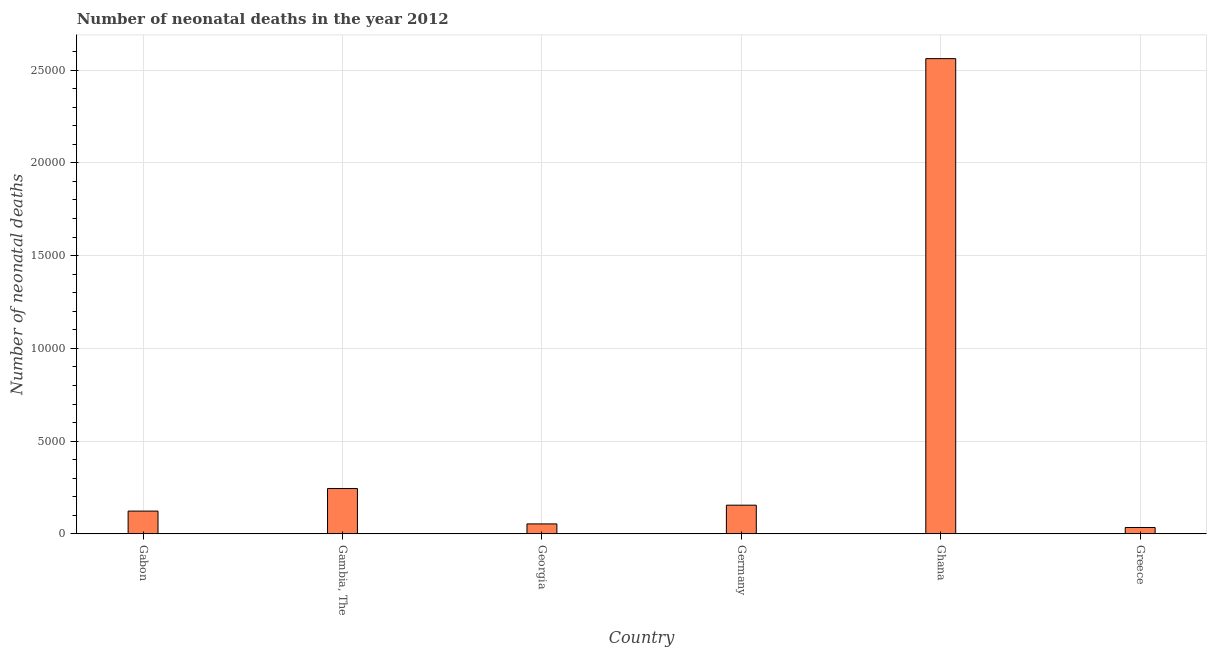Does the graph contain grids?
Your response must be concise. Yes. What is the title of the graph?
Keep it short and to the point. Number of neonatal deaths in the year 2012. What is the label or title of the X-axis?
Keep it short and to the point. Country. What is the label or title of the Y-axis?
Offer a very short reply. Number of neonatal deaths. What is the number of neonatal deaths in Ghana?
Keep it short and to the point. 2.56e+04. Across all countries, what is the maximum number of neonatal deaths?
Offer a terse response. 2.56e+04. Across all countries, what is the minimum number of neonatal deaths?
Provide a succinct answer. 343. In which country was the number of neonatal deaths maximum?
Provide a succinct answer. Ghana. What is the sum of the number of neonatal deaths?
Offer a very short reply. 3.17e+04. What is the difference between the number of neonatal deaths in Georgia and Greece?
Your answer should be compact. 193. What is the average number of neonatal deaths per country?
Provide a succinct answer. 5285. What is the median number of neonatal deaths?
Your answer should be compact. 1387. In how many countries, is the number of neonatal deaths greater than 11000 ?
Your answer should be very brief. 1. What is the ratio of the number of neonatal deaths in Gambia, The to that in Ghana?
Your response must be concise. 0.1. Is the number of neonatal deaths in Gabon less than that in Greece?
Your answer should be very brief. No. Is the difference between the number of neonatal deaths in Gambia, The and Ghana greater than the difference between any two countries?
Offer a very short reply. No. What is the difference between the highest and the second highest number of neonatal deaths?
Your response must be concise. 2.32e+04. Is the sum of the number of neonatal deaths in Gabon and Greece greater than the maximum number of neonatal deaths across all countries?
Give a very brief answer. No. What is the difference between the highest and the lowest number of neonatal deaths?
Provide a succinct answer. 2.53e+04. In how many countries, is the number of neonatal deaths greater than the average number of neonatal deaths taken over all countries?
Provide a short and direct response. 1. How many bars are there?
Make the answer very short. 6. Are all the bars in the graph horizontal?
Offer a terse response. No. Are the values on the major ticks of Y-axis written in scientific E-notation?
Give a very brief answer. No. What is the Number of neonatal deaths in Gabon?
Make the answer very short. 1228. What is the Number of neonatal deaths of Gambia, The?
Provide a succinct answer. 2443. What is the Number of neonatal deaths of Georgia?
Provide a succinct answer. 536. What is the Number of neonatal deaths in Germany?
Make the answer very short. 1546. What is the Number of neonatal deaths of Ghana?
Provide a short and direct response. 2.56e+04. What is the Number of neonatal deaths of Greece?
Give a very brief answer. 343. What is the difference between the Number of neonatal deaths in Gabon and Gambia, The?
Your answer should be compact. -1215. What is the difference between the Number of neonatal deaths in Gabon and Georgia?
Offer a terse response. 692. What is the difference between the Number of neonatal deaths in Gabon and Germany?
Provide a succinct answer. -318. What is the difference between the Number of neonatal deaths in Gabon and Ghana?
Provide a short and direct response. -2.44e+04. What is the difference between the Number of neonatal deaths in Gabon and Greece?
Make the answer very short. 885. What is the difference between the Number of neonatal deaths in Gambia, The and Georgia?
Your answer should be very brief. 1907. What is the difference between the Number of neonatal deaths in Gambia, The and Germany?
Make the answer very short. 897. What is the difference between the Number of neonatal deaths in Gambia, The and Ghana?
Provide a short and direct response. -2.32e+04. What is the difference between the Number of neonatal deaths in Gambia, The and Greece?
Ensure brevity in your answer.  2100. What is the difference between the Number of neonatal deaths in Georgia and Germany?
Keep it short and to the point. -1010. What is the difference between the Number of neonatal deaths in Georgia and Ghana?
Ensure brevity in your answer.  -2.51e+04. What is the difference between the Number of neonatal deaths in Georgia and Greece?
Give a very brief answer. 193. What is the difference between the Number of neonatal deaths in Germany and Ghana?
Offer a terse response. -2.41e+04. What is the difference between the Number of neonatal deaths in Germany and Greece?
Offer a terse response. 1203. What is the difference between the Number of neonatal deaths in Ghana and Greece?
Offer a terse response. 2.53e+04. What is the ratio of the Number of neonatal deaths in Gabon to that in Gambia, The?
Your answer should be compact. 0.5. What is the ratio of the Number of neonatal deaths in Gabon to that in Georgia?
Offer a very short reply. 2.29. What is the ratio of the Number of neonatal deaths in Gabon to that in Germany?
Provide a short and direct response. 0.79. What is the ratio of the Number of neonatal deaths in Gabon to that in Ghana?
Ensure brevity in your answer.  0.05. What is the ratio of the Number of neonatal deaths in Gabon to that in Greece?
Offer a very short reply. 3.58. What is the ratio of the Number of neonatal deaths in Gambia, The to that in Georgia?
Provide a short and direct response. 4.56. What is the ratio of the Number of neonatal deaths in Gambia, The to that in Germany?
Offer a very short reply. 1.58. What is the ratio of the Number of neonatal deaths in Gambia, The to that in Ghana?
Keep it short and to the point. 0.1. What is the ratio of the Number of neonatal deaths in Gambia, The to that in Greece?
Give a very brief answer. 7.12. What is the ratio of the Number of neonatal deaths in Georgia to that in Germany?
Give a very brief answer. 0.35. What is the ratio of the Number of neonatal deaths in Georgia to that in Ghana?
Provide a short and direct response. 0.02. What is the ratio of the Number of neonatal deaths in Georgia to that in Greece?
Keep it short and to the point. 1.56. What is the ratio of the Number of neonatal deaths in Germany to that in Greece?
Ensure brevity in your answer.  4.51. What is the ratio of the Number of neonatal deaths in Ghana to that in Greece?
Offer a very short reply. 74.69. 